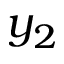Convert formula to latex. <formula><loc_0><loc_0><loc_500><loc_500>y _ { 2 }</formula> 